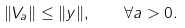Convert formula to latex. <formula><loc_0><loc_0><loc_500><loc_500>\| V _ { a } \| \leq \| y \| , \quad \forall a > 0 .</formula> 